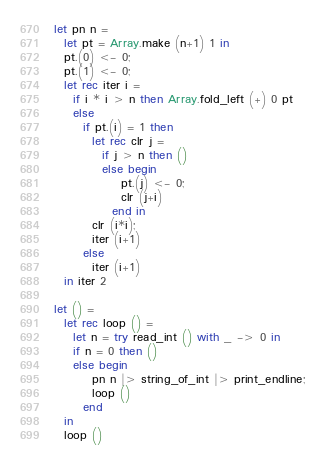<code> <loc_0><loc_0><loc_500><loc_500><_OCaml_>let pn n =
  let pt = Array.make (n+1) 1 in
  pt.(0) <- 0;
  pt.(1) <- 0;
  let rec iter i =
    if i * i > n then Array.fold_left (+) 0 pt
    else
      if pt.(i) = 1 then
        let rec clr j =
          if j > n then ()
          else begin
              pt.(j) <- 0;
              clr (j+i)
            end in
        clr (i*i);
        iter (i+1)
      else
        iter (i+1)
  in iter 2
     
let () =
  let rec loop () =
    let n = try read_int () with _ -> 0 in
    if n = 0 then ()
    else begin
        pn n |> string_of_int |> print_endline;
        loop ()
      end
  in
  loop ()</code> 